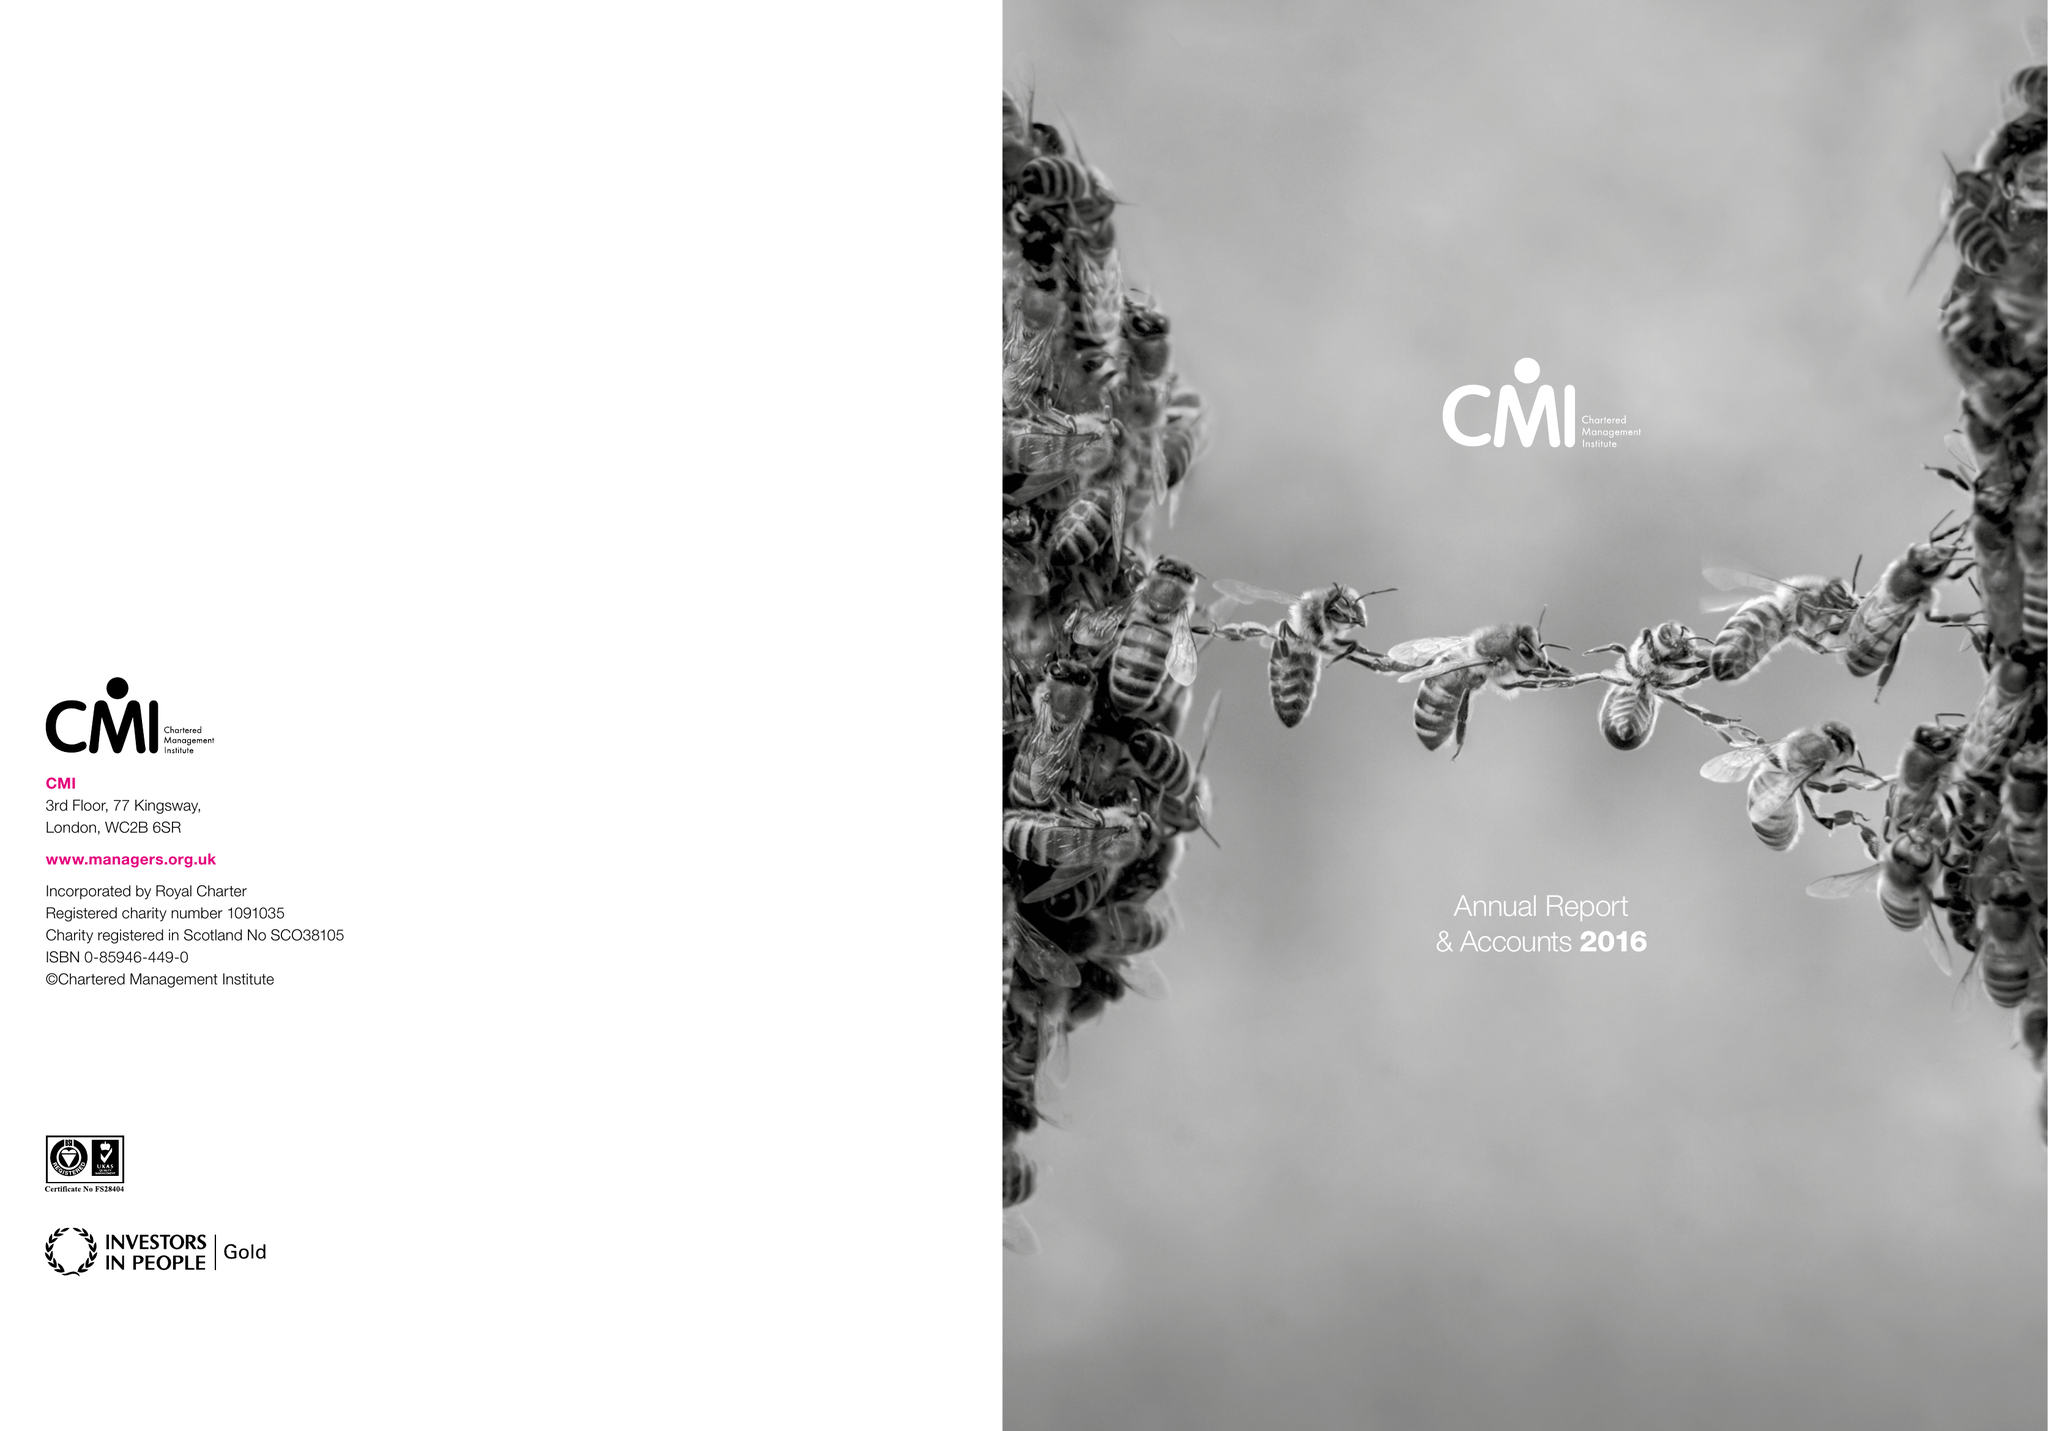What is the value for the charity_name?
Answer the question using a single word or phrase. Chartered Management Institute 